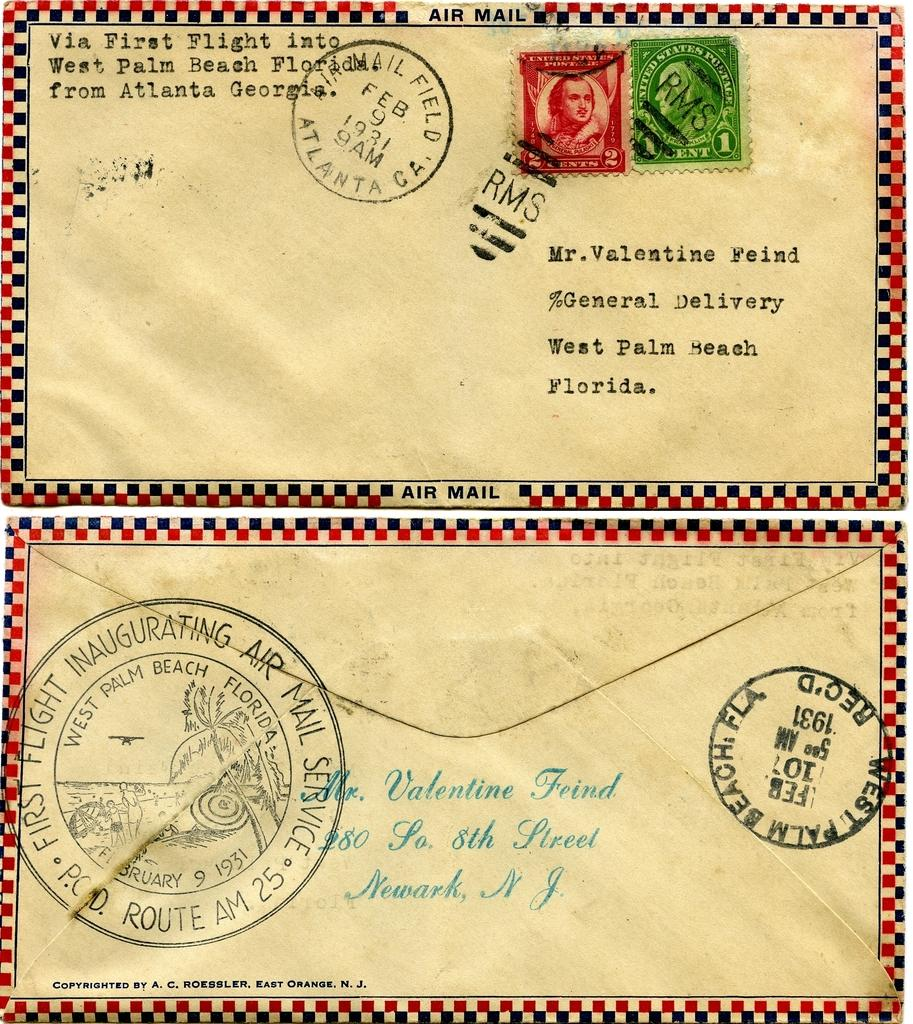Provide a one-sentence caption for the provided image. Two envelopes is addressed to Mr. Valentine Fried with one envelope stamped West Palm Beach Florida on the back and two stamps on the front. 